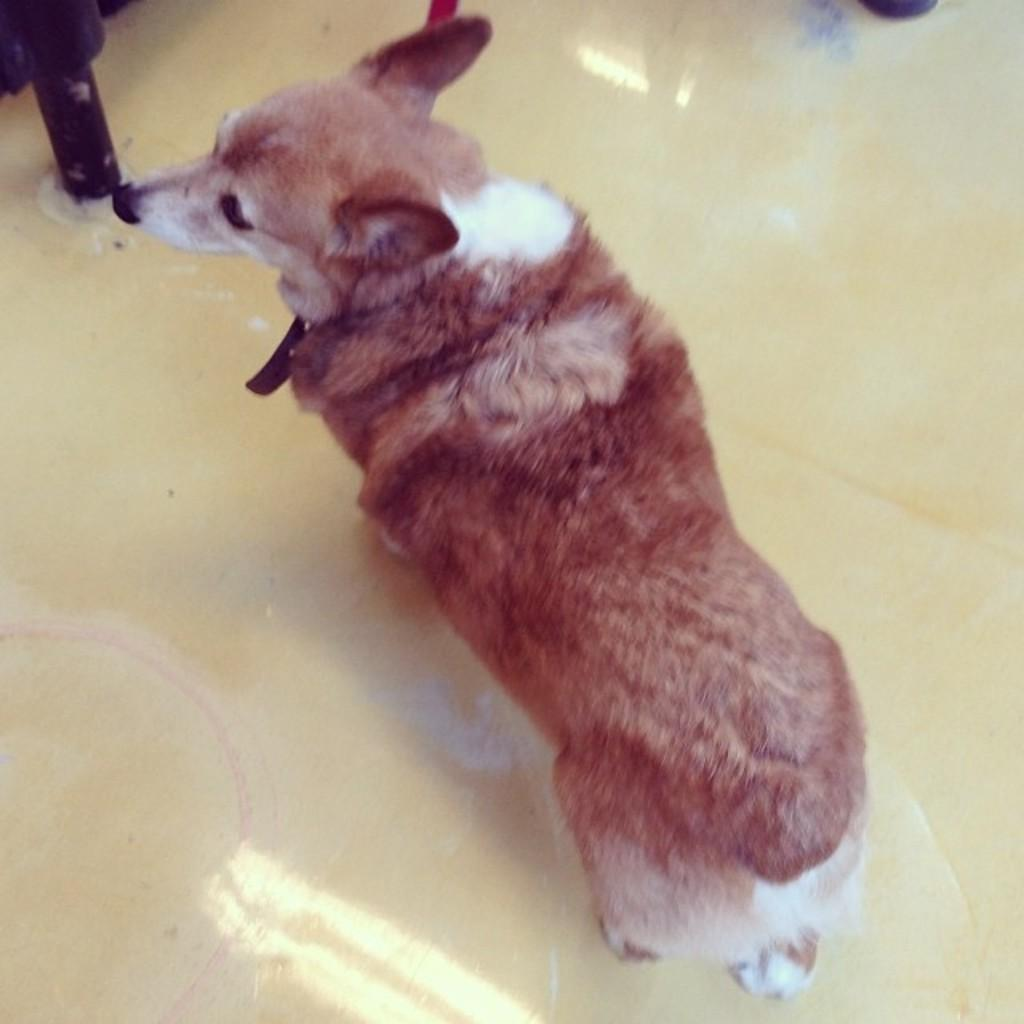What type of animal is present in the image? There is a dog in the image. Can you describe the position of the dog in the image? The dog is standing on the floor. How many kittens are wearing apparel in the image? There are no kittens or apparel present in the image; it features a dog standing on the floor. 